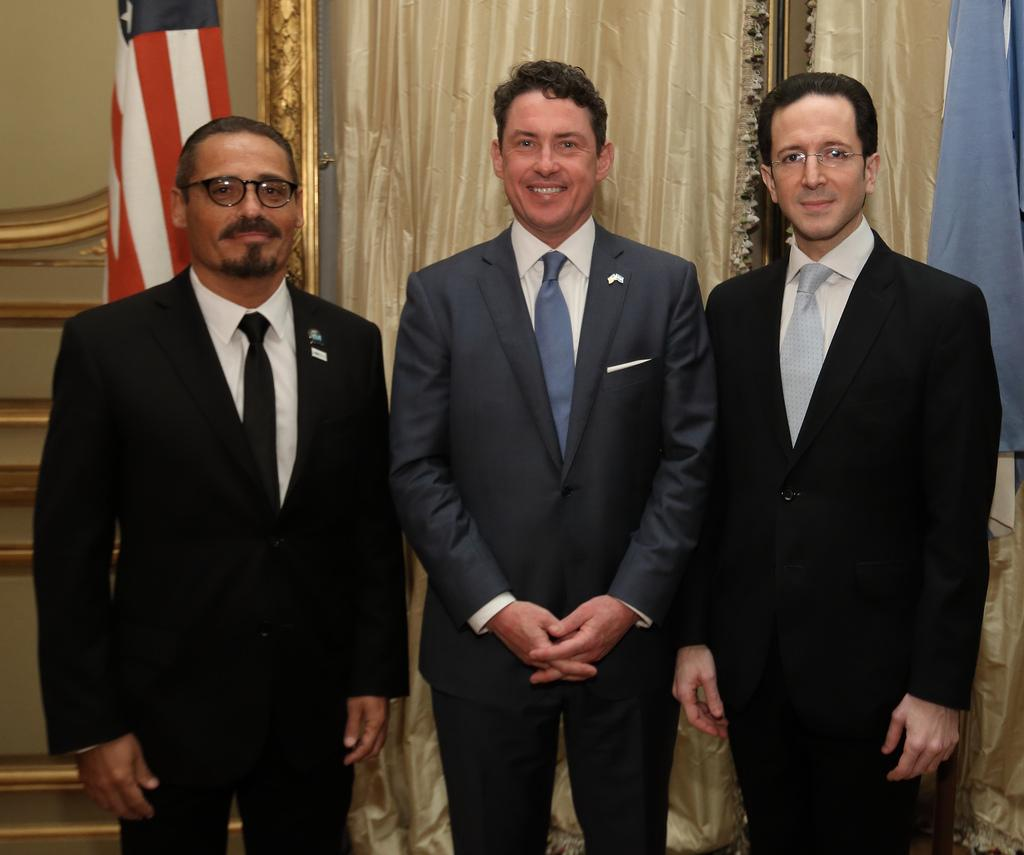How many people are in the foreground of the image? There are three persons in the foreground of the image. What are the persons wearing? The persons are wearing suits. What is the facial expression of the persons? The persons are smiling. Where are the persons standing? The persons are standing on the ground. What can be seen in the background of the image? There are curtains and a flag in the background of the image. What type of cabbage is being used as a hat by one of the persons in the image? There is no cabbage present in the image, and no one is wearing a cabbage as a hat. Are the three persons in the image sisters? The provided facts do not mention any familial relationship between the persons, so we cannot determine if they are sisters. 